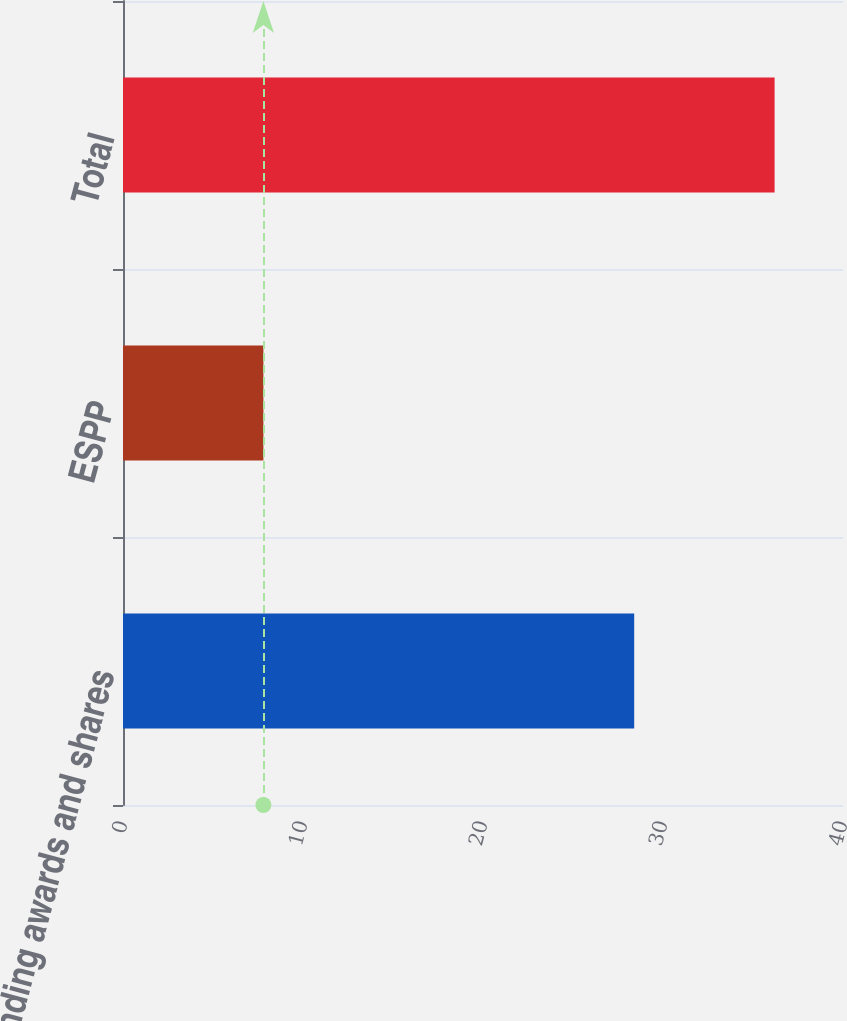Convert chart to OTSL. <chart><loc_0><loc_0><loc_500><loc_500><bar_chart><fcel>Outstanding awards and shares<fcel>ESPP<fcel>Total<nl><fcel>28.4<fcel>7.8<fcel>36.2<nl></chart> 